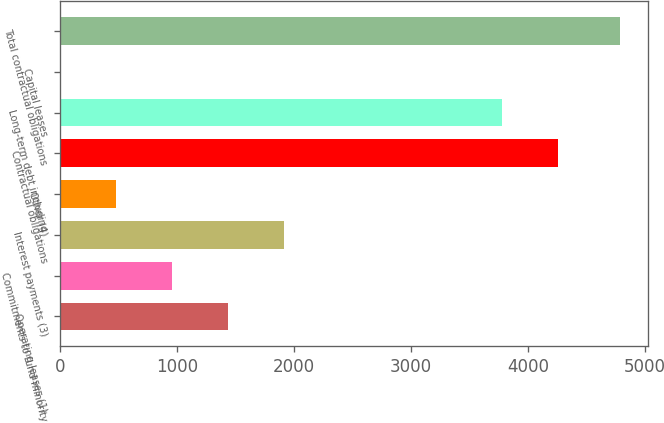Convert chart. <chart><loc_0><loc_0><loc_500><loc_500><bar_chart><fcel>Operating leases (1)<fcel>Commitments to fund minority<fcel>Interest payments (3)<fcel>Other (4)<fcel>Contractual obligations<fcel>Long-term debt including<fcel>Capital leases<fcel>Total contractual obligations<nl><fcel>1437.5<fcel>959<fcel>1916<fcel>480.5<fcel>4252.5<fcel>3774<fcel>2<fcel>4787<nl></chart> 